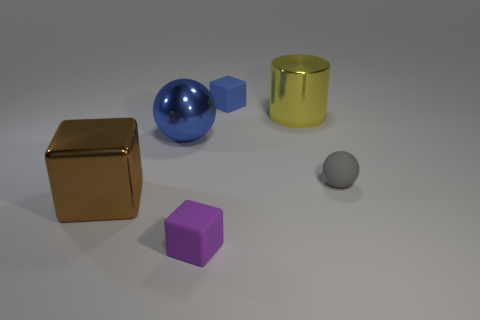Is there any other thing that has the same shape as the yellow shiny thing?
Make the answer very short. No. How many things are either big green rubber things or rubber cubes behind the blue ball?
Offer a terse response. 1. There is a big object that is to the right of the small rubber cube that is in front of the blue metal ball; how many large metal things are behind it?
Make the answer very short. 0. What material is the purple thing that is the same size as the gray ball?
Provide a succinct answer. Rubber. Is there a blue object that has the same size as the brown cube?
Make the answer very short. Yes. The metallic block is what color?
Give a very brief answer. Brown. What is the color of the big object to the right of the small matte cube in front of the big yellow metallic cylinder?
Your response must be concise. Yellow. There is a large metallic object behind the blue thing on the left side of the rubber block to the left of the small blue rubber cube; what shape is it?
Provide a short and direct response. Cylinder. What number of tiny cubes have the same material as the small gray thing?
Ensure brevity in your answer.  2. How many matte blocks are behind the cube to the right of the purple matte thing?
Ensure brevity in your answer.  0. 